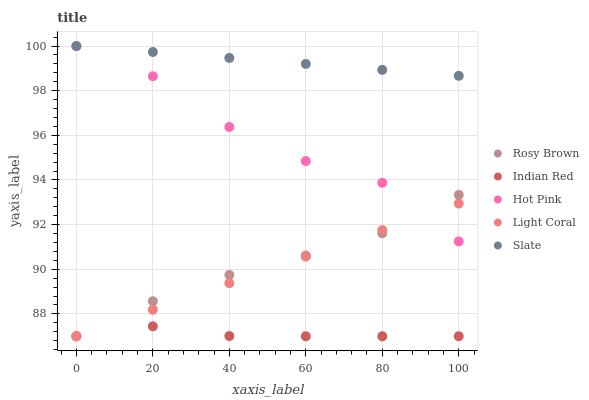Does Indian Red have the minimum area under the curve?
Answer yes or no. Yes. Does Slate have the maximum area under the curve?
Answer yes or no. Yes. Does Rosy Brown have the minimum area under the curve?
Answer yes or no. No. Does Rosy Brown have the maximum area under the curve?
Answer yes or no. No. Is Light Coral the smoothest?
Answer yes or no. Yes. Is Hot Pink the roughest?
Answer yes or no. Yes. Is Slate the smoothest?
Answer yes or no. No. Is Slate the roughest?
Answer yes or no. No. Does Light Coral have the lowest value?
Answer yes or no. Yes. Does Slate have the lowest value?
Answer yes or no. No. Does Slate have the highest value?
Answer yes or no. Yes. Does Rosy Brown have the highest value?
Answer yes or no. No. Is Hot Pink less than Slate?
Answer yes or no. Yes. Is Slate greater than Hot Pink?
Answer yes or no. Yes. Does Hot Pink intersect Light Coral?
Answer yes or no. Yes. Is Hot Pink less than Light Coral?
Answer yes or no. No. Is Hot Pink greater than Light Coral?
Answer yes or no. No. Does Hot Pink intersect Slate?
Answer yes or no. No. 